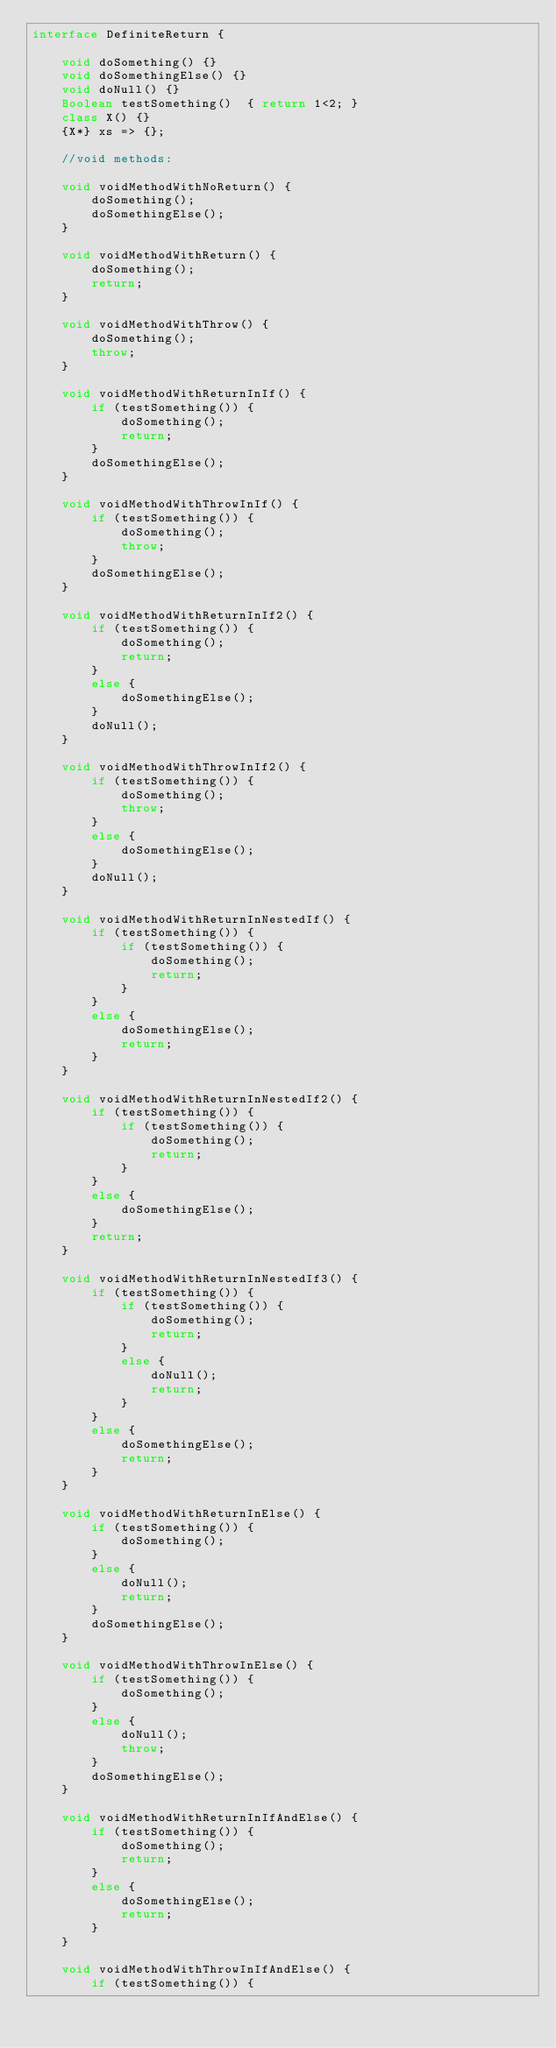<code> <loc_0><loc_0><loc_500><loc_500><_Ceylon_>interface DefiniteReturn {
        
    void doSomething() {}
    void doSomethingElse() {}
    void doNull() {}
    Boolean testSomething()  { return 1<2; }
    class X() {}
    {X*} xs => {};
    
    //void methods:
    
    void voidMethodWithNoReturn() {
        doSomething();
        doSomethingElse();
    }
    
    void voidMethodWithReturn() {
        doSomething();
        return;
    }
    
    void voidMethodWithThrow() {
        doSomething();
        throw;
    }
    
    void voidMethodWithReturnInIf() {
        if (testSomething()) {
            doSomething();
            return;
        }
        doSomethingElse();
    }
    
    void voidMethodWithThrowInIf() {
        if (testSomething()) {
            doSomething();
            throw;
        }
        doSomethingElse();
    }
    
    void voidMethodWithReturnInIf2() {
        if (testSomething()) {
            doSomething();
            return;
        }
        else {
            doSomethingElse();
        }
        doNull();
    }
    
    void voidMethodWithThrowInIf2() {
        if (testSomething()) {
            doSomething();
            throw;
        }
        else {
            doSomethingElse();
        }
        doNull();
    }
    
    void voidMethodWithReturnInNestedIf() {
        if (testSomething()) {
            if (testSomething()) {
                doSomething();
                return;
            }
        }
        else {
            doSomethingElse();
            return;
        }
    }
    
    void voidMethodWithReturnInNestedIf2() {
        if (testSomething()) {
            if (testSomething()) {
                doSomething();
                return;
            }
        }
        else {
            doSomethingElse();
        }
        return;
    }
    
    void voidMethodWithReturnInNestedIf3() {
        if (testSomething()) {
            if (testSomething()) {
                doSomething();
                return;
            }
            else {
                doNull();
                return;
            }
        }
        else {
            doSomethingElse();
            return;
        }
    }
    
    void voidMethodWithReturnInElse() {
        if (testSomething()) {
            doSomething();
        }
        else {
            doNull();
            return;
        }
        doSomethingElse();
    }
    
    void voidMethodWithThrowInElse() {
        if (testSomething()) {
            doSomething();
        }
        else {
            doNull();
            throw;
        }
        doSomethingElse();
    }
    
    void voidMethodWithReturnInIfAndElse() {
        if (testSomething()) {
            doSomething();
            return;
        }
        else {
            doSomethingElse();
            return;
        }
    }
    
    void voidMethodWithThrowInIfAndElse() {
        if (testSomething()) {</code> 